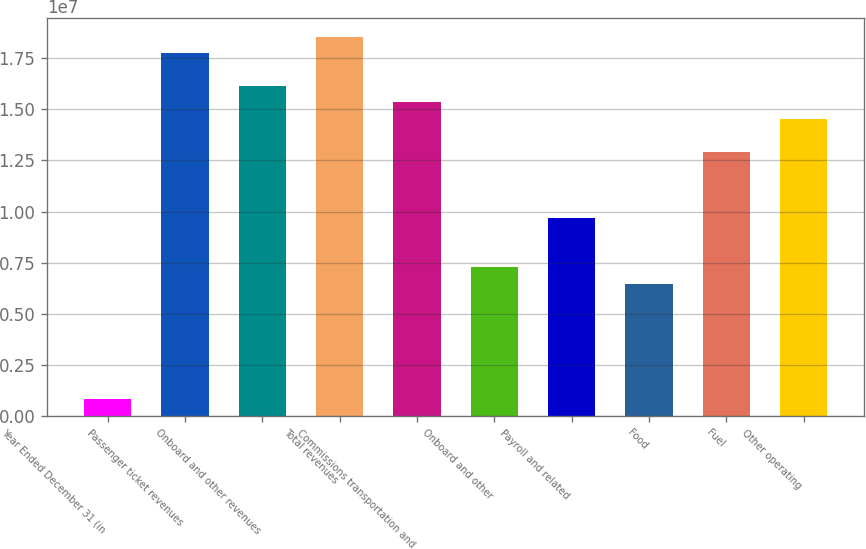<chart> <loc_0><loc_0><loc_500><loc_500><bar_chart><fcel>Year Ended December 31 (in<fcel>Passenger ticket revenues<fcel>Onboard and other revenues<fcel>Total revenues<fcel>Commissions transportation and<fcel>Onboard and other<fcel>Payroll and related<fcel>Food<fcel>Fuel<fcel>Other operating<nl><fcel>807389<fcel>1.77625e+07<fcel>1.61477e+07<fcel>1.85699e+07<fcel>1.53403e+07<fcel>7.26647e+06<fcel>9.68863e+06<fcel>6.45908e+06<fcel>1.29182e+07<fcel>1.45329e+07<nl></chart> 